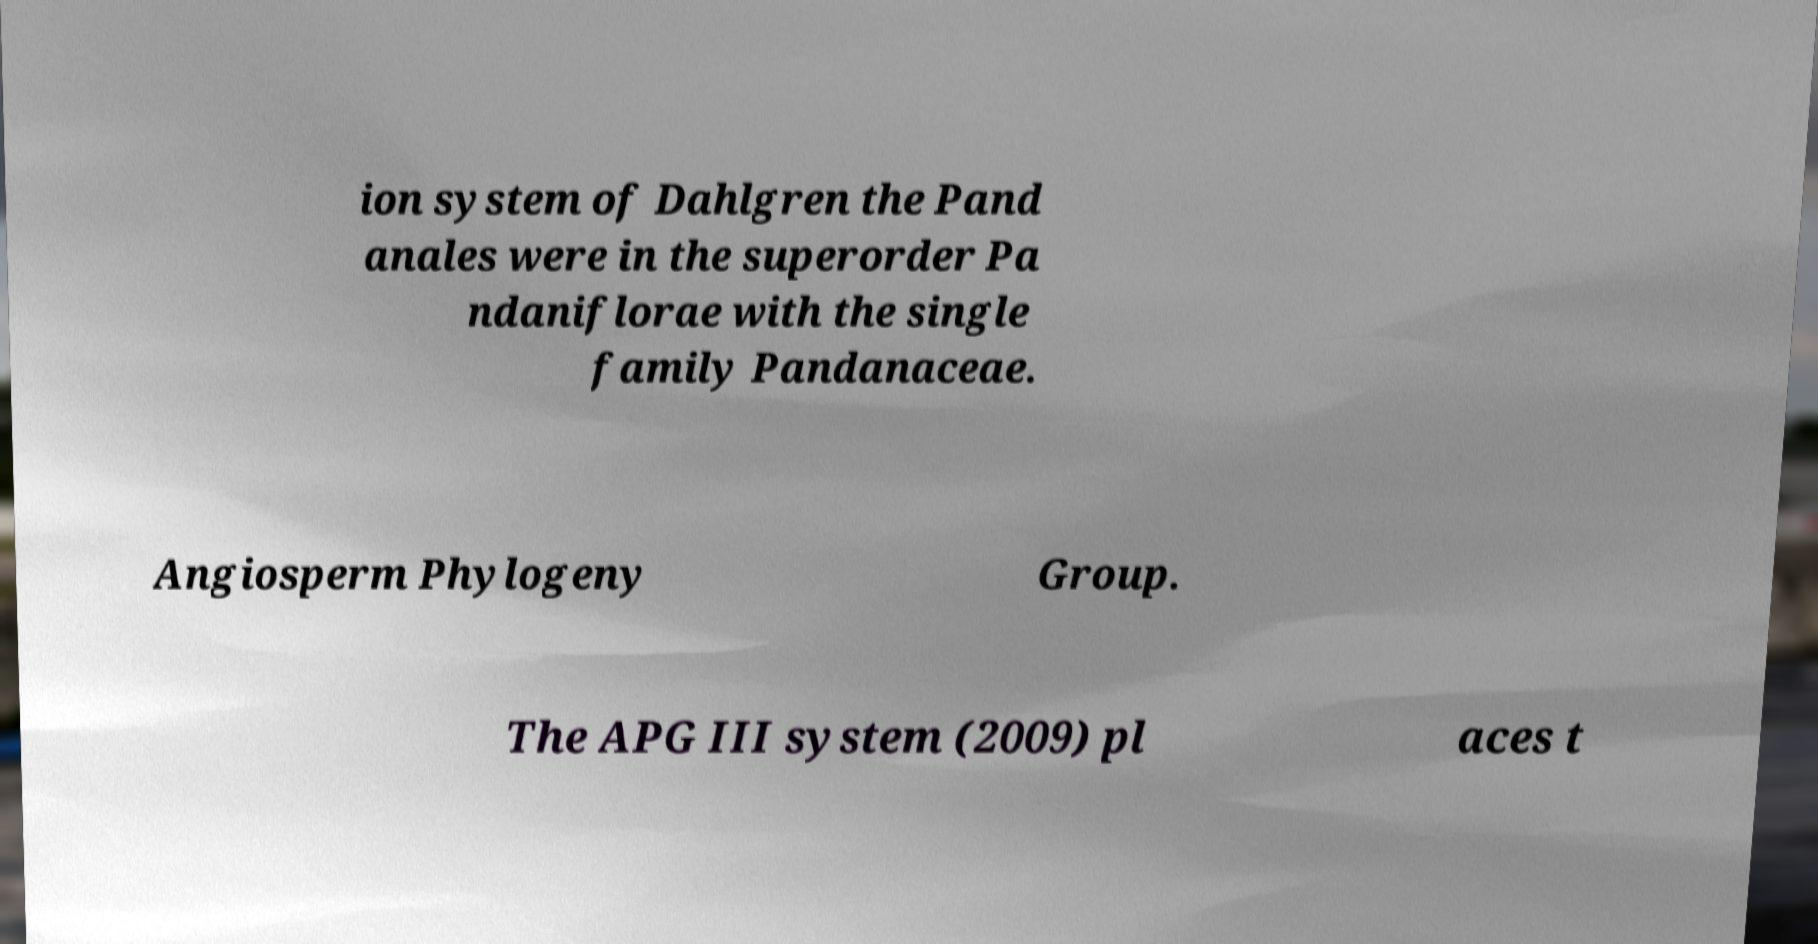For documentation purposes, I need the text within this image transcribed. Could you provide that? ion system of Dahlgren the Pand anales were in the superorder Pa ndaniflorae with the single family Pandanaceae. Angiosperm Phylogeny Group. The APG III system (2009) pl aces t 